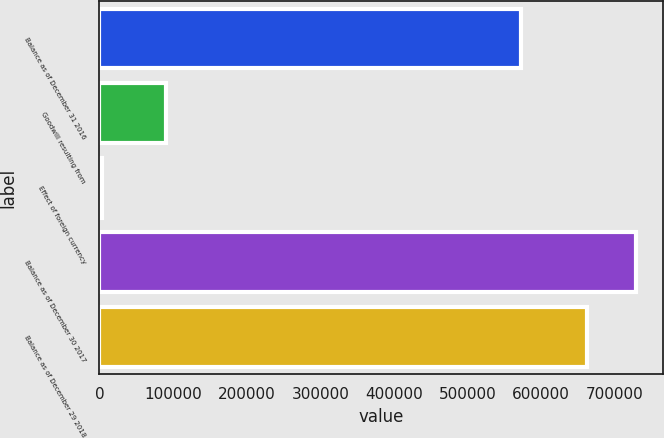<chart> <loc_0><loc_0><loc_500><loc_500><bar_chart><fcel>Balance as of December 31 2016<fcel>Goodwill resulting from<fcel>Effect of foreign currency<fcel>Balance as of December 30 2017<fcel>Balance as of December 29 2018<nl><fcel>572764<fcel>90218<fcel>3027<fcel>728570<fcel>662272<nl></chart> 